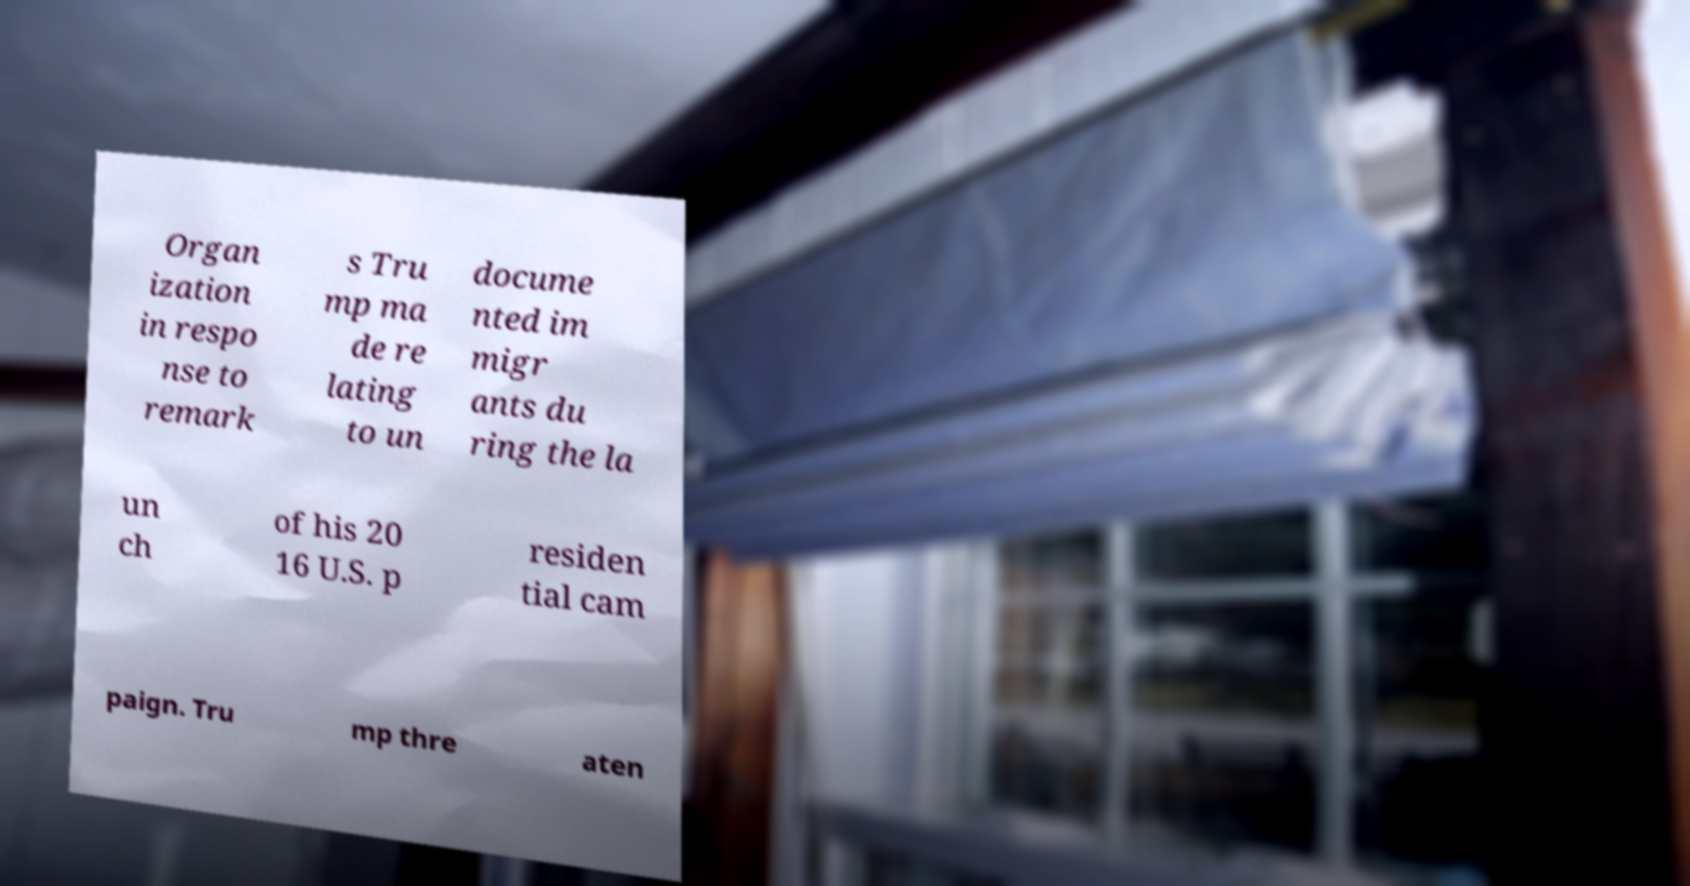Please identify and transcribe the text found in this image. Organ ization in respo nse to remark s Tru mp ma de re lating to un docume nted im migr ants du ring the la un ch of his 20 16 U.S. p residen tial cam paign. Tru mp thre aten 